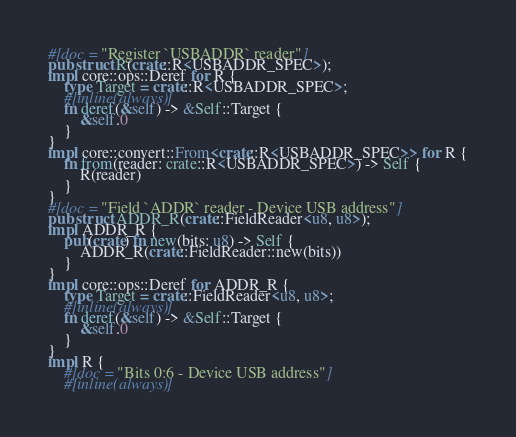<code> <loc_0><loc_0><loc_500><loc_500><_Rust_>#[doc = "Register `USBADDR` reader"]
pub struct R(crate::R<USBADDR_SPEC>);
impl core::ops::Deref for R {
    type Target = crate::R<USBADDR_SPEC>;
    #[inline(always)]
    fn deref(&self) -> &Self::Target {
        &self.0
    }
}
impl core::convert::From<crate::R<USBADDR_SPEC>> for R {
    fn from(reader: crate::R<USBADDR_SPEC>) -> Self {
        R(reader)
    }
}
#[doc = "Field `ADDR` reader - Device USB address"]
pub struct ADDR_R(crate::FieldReader<u8, u8>);
impl ADDR_R {
    pub(crate) fn new(bits: u8) -> Self {
        ADDR_R(crate::FieldReader::new(bits))
    }
}
impl core::ops::Deref for ADDR_R {
    type Target = crate::FieldReader<u8, u8>;
    #[inline(always)]
    fn deref(&self) -> &Self::Target {
        &self.0
    }
}
impl R {
    #[doc = "Bits 0:6 - Device USB address"]
    #[inline(always)]</code> 